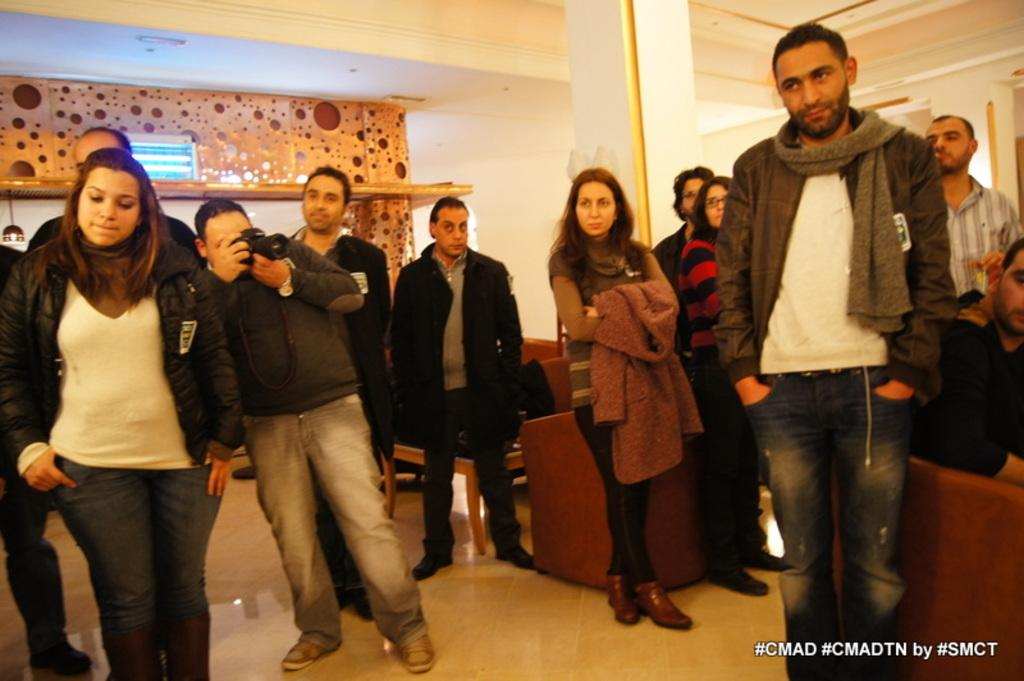<image>
Describe the image concisely. A group of people are standing in a room and there are hashtags in the corner that say #CMAD #CMADTN by #SMCT. 